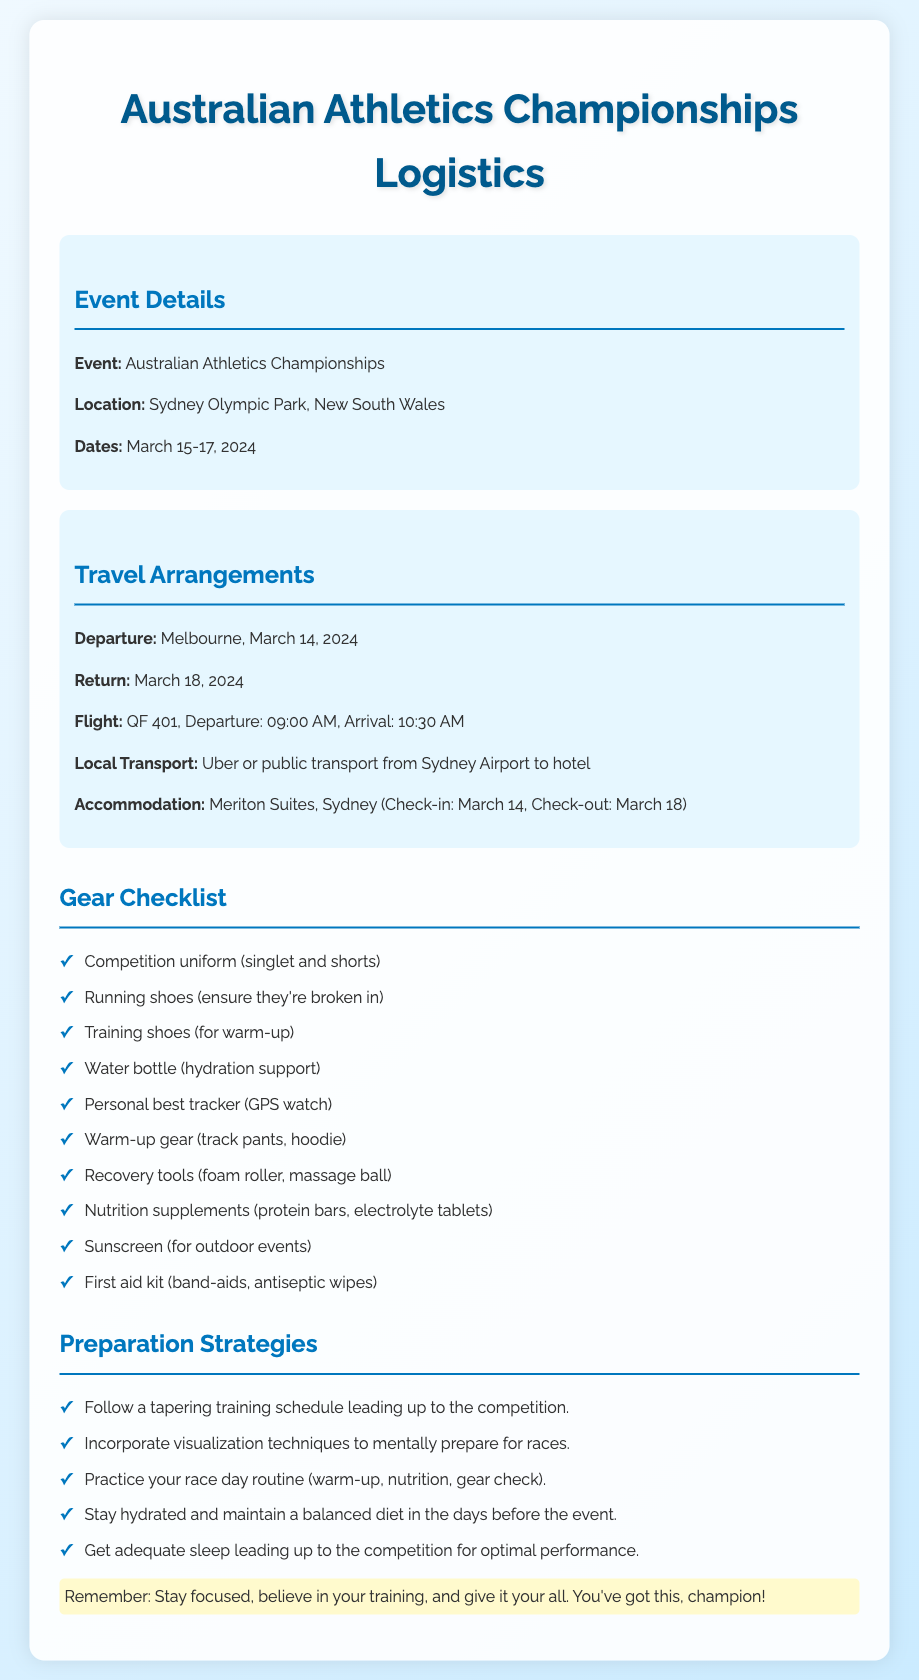What are the event dates? The event dates are specifically mentioned in the document as March 15-17, 2024.
Answer: March 15-17, 2024 Where is the competition taking place? The location of the event is explicitly stated in the document as Sydney Olympic Park, New South Wales.
Answer: Sydney Olympic Park, New South Wales What is the flight number for the competition? The flight number for the travel arrangement is detailed in the document as QF 401.
Answer: QF 401 What should I bring for hydration support? The gear checklist mentions a specific item for hydration support is a water bottle.
Answer: Water bottle What is one key preparation strategy mentioned? The preparation strategies include several items, one of which is incorporating visualization techniques to mentally prepare for races.
Answer: Incorporate visualization techniques How should I travel from the airport to the hotel? The document specifies the local transport options as Uber or public transport from Sydney Airport to hotel.
Answer: Uber or public transport When should I check out of the hotel? The document provides the check-out date as March 18, 2024.
Answer: March 18, 2024 What is a recommended nutrition supplement to bring? The travel gear checklist includes nutrition supplements, specifically mentioning protein bars and electrolyte tablets.
Answer: Protein bars What should I do to ensure my running shoes are ready? The checklist advises ensuring running shoes are broken in before the event.
Answer: Ensure they're broken in 